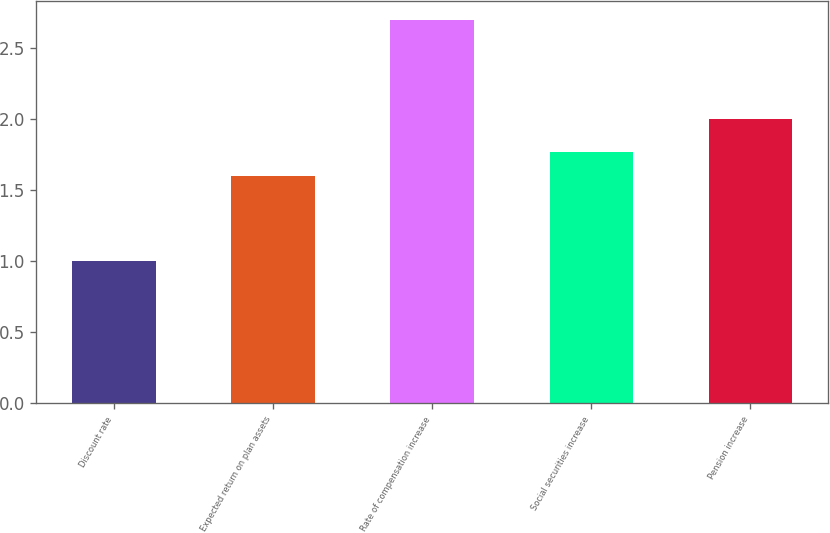<chart> <loc_0><loc_0><loc_500><loc_500><bar_chart><fcel>Discount rate<fcel>Expected return on plan assets<fcel>Rate of compensation increase<fcel>Social securities increase<fcel>Pension increase<nl><fcel>1<fcel>1.6<fcel>2.7<fcel>1.77<fcel>2<nl></chart> 